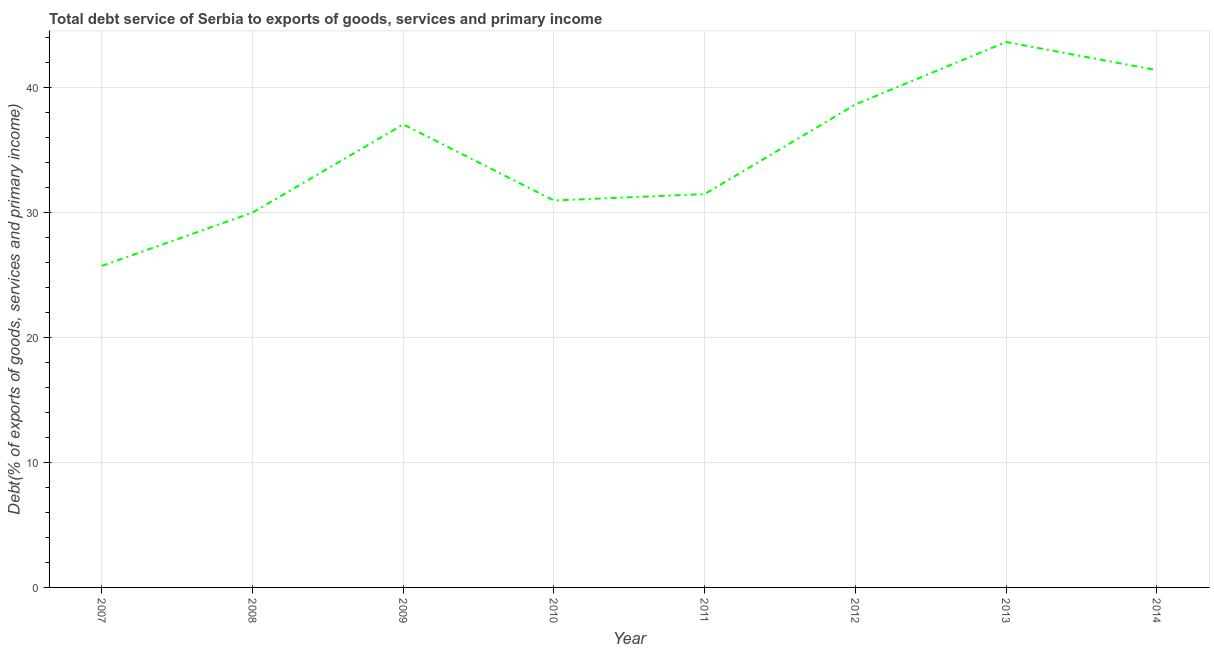What is the total debt service in 2012?
Offer a terse response. 38.63. Across all years, what is the maximum total debt service?
Make the answer very short. 43.63. Across all years, what is the minimum total debt service?
Provide a succinct answer. 25.72. In which year was the total debt service maximum?
Offer a terse response. 2013. In which year was the total debt service minimum?
Your response must be concise. 2007. What is the sum of the total debt service?
Give a very brief answer. 278.79. What is the difference between the total debt service in 2009 and 2014?
Keep it short and to the point. -4.34. What is the average total debt service per year?
Offer a terse response. 34.85. What is the median total debt service?
Offer a very short reply. 34.25. In how many years, is the total debt service greater than 20 %?
Give a very brief answer. 8. What is the ratio of the total debt service in 2008 to that in 2011?
Provide a short and direct response. 0.95. Is the total debt service in 2008 less than that in 2010?
Offer a very short reply. Yes. What is the difference between the highest and the second highest total debt service?
Your response must be concise. 2.25. What is the difference between the highest and the lowest total debt service?
Your response must be concise. 17.91. Does the total debt service monotonically increase over the years?
Make the answer very short. No. How many lines are there?
Your answer should be very brief. 1. How many years are there in the graph?
Make the answer very short. 8. What is the difference between two consecutive major ticks on the Y-axis?
Your answer should be compact. 10. Are the values on the major ticks of Y-axis written in scientific E-notation?
Your answer should be compact. No. Does the graph contain grids?
Provide a short and direct response. Yes. What is the title of the graph?
Your answer should be compact. Total debt service of Serbia to exports of goods, services and primary income. What is the label or title of the Y-axis?
Ensure brevity in your answer.  Debt(% of exports of goods, services and primary income). What is the Debt(% of exports of goods, services and primary income) of 2007?
Your response must be concise. 25.72. What is the Debt(% of exports of goods, services and primary income) in 2008?
Offer a very short reply. 29.99. What is the Debt(% of exports of goods, services and primary income) in 2009?
Offer a very short reply. 37.04. What is the Debt(% of exports of goods, services and primary income) of 2010?
Keep it short and to the point. 30.95. What is the Debt(% of exports of goods, services and primary income) of 2011?
Provide a short and direct response. 31.46. What is the Debt(% of exports of goods, services and primary income) in 2012?
Offer a terse response. 38.63. What is the Debt(% of exports of goods, services and primary income) in 2013?
Your response must be concise. 43.63. What is the Debt(% of exports of goods, services and primary income) in 2014?
Provide a short and direct response. 41.38. What is the difference between the Debt(% of exports of goods, services and primary income) in 2007 and 2008?
Offer a terse response. -4.27. What is the difference between the Debt(% of exports of goods, services and primary income) in 2007 and 2009?
Your response must be concise. -11.32. What is the difference between the Debt(% of exports of goods, services and primary income) in 2007 and 2010?
Provide a succinct answer. -5.23. What is the difference between the Debt(% of exports of goods, services and primary income) in 2007 and 2011?
Give a very brief answer. -5.74. What is the difference between the Debt(% of exports of goods, services and primary income) in 2007 and 2012?
Provide a short and direct response. -12.91. What is the difference between the Debt(% of exports of goods, services and primary income) in 2007 and 2013?
Provide a short and direct response. -17.91. What is the difference between the Debt(% of exports of goods, services and primary income) in 2007 and 2014?
Your answer should be very brief. -15.66. What is the difference between the Debt(% of exports of goods, services and primary income) in 2008 and 2009?
Offer a very short reply. -7.05. What is the difference between the Debt(% of exports of goods, services and primary income) in 2008 and 2010?
Give a very brief answer. -0.96. What is the difference between the Debt(% of exports of goods, services and primary income) in 2008 and 2011?
Make the answer very short. -1.48. What is the difference between the Debt(% of exports of goods, services and primary income) in 2008 and 2012?
Offer a very short reply. -8.64. What is the difference between the Debt(% of exports of goods, services and primary income) in 2008 and 2013?
Offer a terse response. -13.64. What is the difference between the Debt(% of exports of goods, services and primary income) in 2008 and 2014?
Make the answer very short. -11.39. What is the difference between the Debt(% of exports of goods, services and primary income) in 2009 and 2010?
Ensure brevity in your answer.  6.09. What is the difference between the Debt(% of exports of goods, services and primary income) in 2009 and 2011?
Give a very brief answer. 5.58. What is the difference between the Debt(% of exports of goods, services and primary income) in 2009 and 2012?
Ensure brevity in your answer.  -1.59. What is the difference between the Debt(% of exports of goods, services and primary income) in 2009 and 2013?
Your answer should be compact. -6.59. What is the difference between the Debt(% of exports of goods, services and primary income) in 2009 and 2014?
Offer a terse response. -4.34. What is the difference between the Debt(% of exports of goods, services and primary income) in 2010 and 2011?
Provide a short and direct response. -0.51. What is the difference between the Debt(% of exports of goods, services and primary income) in 2010 and 2012?
Provide a short and direct response. -7.68. What is the difference between the Debt(% of exports of goods, services and primary income) in 2010 and 2013?
Your answer should be compact. -12.68. What is the difference between the Debt(% of exports of goods, services and primary income) in 2010 and 2014?
Your response must be concise. -10.43. What is the difference between the Debt(% of exports of goods, services and primary income) in 2011 and 2012?
Your answer should be compact. -7.17. What is the difference between the Debt(% of exports of goods, services and primary income) in 2011 and 2013?
Provide a succinct answer. -12.16. What is the difference between the Debt(% of exports of goods, services and primary income) in 2011 and 2014?
Provide a succinct answer. -9.92. What is the difference between the Debt(% of exports of goods, services and primary income) in 2012 and 2013?
Make the answer very short. -5. What is the difference between the Debt(% of exports of goods, services and primary income) in 2012 and 2014?
Offer a very short reply. -2.75. What is the difference between the Debt(% of exports of goods, services and primary income) in 2013 and 2014?
Your answer should be compact. 2.25. What is the ratio of the Debt(% of exports of goods, services and primary income) in 2007 to that in 2008?
Offer a very short reply. 0.86. What is the ratio of the Debt(% of exports of goods, services and primary income) in 2007 to that in 2009?
Offer a very short reply. 0.69. What is the ratio of the Debt(% of exports of goods, services and primary income) in 2007 to that in 2010?
Keep it short and to the point. 0.83. What is the ratio of the Debt(% of exports of goods, services and primary income) in 2007 to that in 2011?
Give a very brief answer. 0.82. What is the ratio of the Debt(% of exports of goods, services and primary income) in 2007 to that in 2012?
Your response must be concise. 0.67. What is the ratio of the Debt(% of exports of goods, services and primary income) in 2007 to that in 2013?
Give a very brief answer. 0.59. What is the ratio of the Debt(% of exports of goods, services and primary income) in 2007 to that in 2014?
Keep it short and to the point. 0.62. What is the ratio of the Debt(% of exports of goods, services and primary income) in 2008 to that in 2009?
Make the answer very short. 0.81. What is the ratio of the Debt(% of exports of goods, services and primary income) in 2008 to that in 2010?
Your answer should be compact. 0.97. What is the ratio of the Debt(% of exports of goods, services and primary income) in 2008 to that in 2011?
Provide a short and direct response. 0.95. What is the ratio of the Debt(% of exports of goods, services and primary income) in 2008 to that in 2012?
Keep it short and to the point. 0.78. What is the ratio of the Debt(% of exports of goods, services and primary income) in 2008 to that in 2013?
Offer a very short reply. 0.69. What is the ratio of the Debt(% of exports of goods, services and primary income) in 2008 to that in 2014?
Offer a very short reply. 0.72. What is the ratio of the Debt(% of exports of goods, services and primary income) in 2009 to that in 2010?
Your answer should be very brief. 1.2. What is the ratio of the Debt(% of exports of goods, services and primary income) in 2009 to that in 2011?
Provide a short and direct response. 1.18. What is the ratio of the Debt(% of exports of goods, services and primary income) in 2009 to that in 2013?
Give a very brief answer. 0.85. What is the ratio of the Debt(% of exports of goods, services and primary income) in 2009 to that in 2014?
Provide a short and direct response. 0.9. What is the ratio of the Debt(% of exports of goods, services and primary income) in 2010 to that in 2011?
Your response must be concise. 0.98. What is the ratio of the Debt(% of exports of goods, services and primary income) in 2010 to that in 2012?
Give a very brief answer. 0.8. What is the ratio of the Debt(% of exports of goods, services and primary income) in 2010 to that in 2013?
Provide a succinct answer. 0.71. What is the ratio of the Debt(% of exports of goods, services and primary income) in 2010 to that in 2014?
Ensure brevity in your answer.  0.75. What is the ratio of the Debt(% of exports of goods, services and primary income) in 2011 to that in 2012?
Provide a succinct answer. 0.81. What is the ratio of the Debt(% of exports of goods, services and primary income) in 2011 to that in 2013?
Offer a very short reply. 0.72. What is the ratio of the Debt(% of exports of goods, services and primary income) in 2011 to that in 2014?
Give a very brief answer. 0.76. What is the ratio of the Debt(% of exports of goods, services and primary income) in 2012 to that in 2013?
Your answer should be very brief. 0.89. What is the ratio of the Debt(% of exports of goods, services and primary income) in 2012 to that in 2014?
Keep it short and to the point. 0.93. What is the ratio of the Debt(% of exports of goods, services and primary income) in 2013 to that in 2014?
Provide a succinct answer. 1.05. 